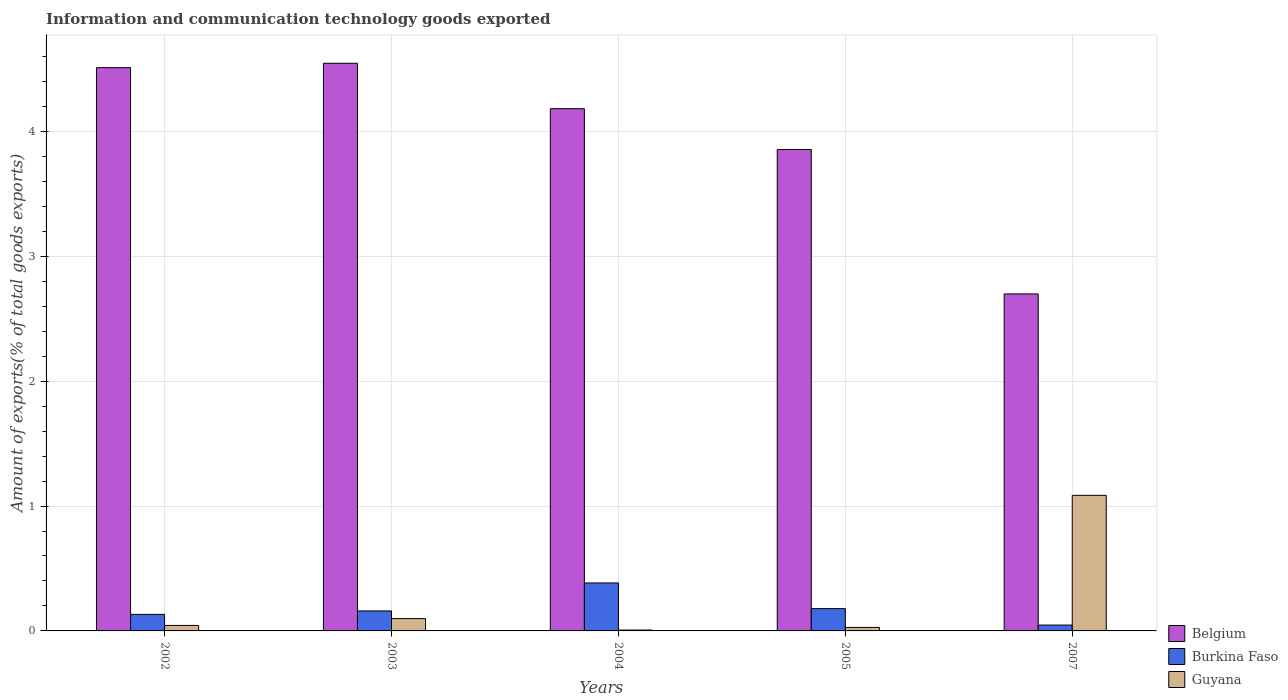How many different coloured bars are there?
Provide a short and direct response. 3. How many groups of bars are there?
Your answer should be compact. 5. How many bars are there on the 3rd tick from the right?
Make the answer very short. 3. What is the amount of goods exported in Belgium in 2005?
Keep it short and to the point. 3.86. Across all years, what is the maximum amount of goods exported in Guyana?
Ensure brevity in your answer.  1.09. Across all years, what is the minimum amount of goods exported in Guyana?
Make the answer very short. 0.01. In which year was the amount of goods exported in Burkina Faso maximum?
Offer a terse response. 2004. In which year was the amount of goods exported in Burkina Faso minimum?
Offer a terse response. 2007. What is the total amount of goods exported in Burkina Faso in the graph?
Give a very brief answer. 0.9. What is the difference between the amount of goods exported in Burkina Faso in 2005 and that in 2007?
Offer a very short reply. 0.13. What is the difference between the amount of goods exported in Guyana in 2005 and the amount of goods exported in Burkina Faso in 2002?
Keep it short and to the point. -0.1. What is the average amount of goods exported in Belgium per year?
Keep it short and to the point. 3.96. In the year 2007, what is the difference between the amount of goods exported in Burkina Faso and amount of goods exported in Belgium?
Make the answer very short. -2.65. In how many years, is the amount of goods exported in Belgium greater than 3 %?
Your response must be concise. 4. What is the ratio of the amount of goods exported in Guyana in 2002 to that in 2005?
Your response must be concise. 1.57. Is the difference between the amount of goods exported in Burkina Faso in 2003 and 2007 greater than the difference between the amount of goods exported in Belgium in 2003 and 2007?
Your response must be concise. No. What is the difference between the highest and the second highest amount of goods exported in Belgium?
Give a very brief answer. 0.04. What is the difference between the highest and the lowest amount of goods exported in Guyana?
Provide a succinct answer. 1.08. Is the sum of the amount of goods exported in Guyana in 2002 and 2005 greater than the maximum amount of goods exported in Burkina Faso across all years?
Your answer should be very brief. No. What does the 3rd bar from the left in 2002 represents?
Your answer should be compact. Guyana. What does the 2nd bar from the right in 2005 represents?
Keep it short and to the point. Burkina Faso. How many bars are there?
Offer a very short reply. 15. How many years are there in the graph?
Make the answer very short. 5. Does the graph contain any zero values?
Make the answer very short. No. What is the title of the graph?
Your answer should be very brief. Information and communication technology goods exported. Does "Cameroon" appear as one of the legend labels in the graph?
Your response must be concise. No. What is the label or title of the X-axis?
Give a very brief answer. Years. What is the label or title of the Y-axis?
Provide a succinct answer. Amount of exports(% of total goods exports). What is the Amount of exports(% of total goods exports) of Belgium in 2002?
Give a very brief answer. 4.51. What is the Amount of exports(% of total goods exports) of Burkina Faso in 2002?
Provide a succinct answer. 0.13. What is the Amount of exports(% of total goods exports) of Guyana in 2002?
Your answer should be very brief. 0.04. What is the Amount of exports(% of total goods exports) of Belgium in 2003?
Your response must be concise. 4.55. What is the Amount of exports(% of total goods exports) in Burkina Faso in 2003?
Make the answer very short. 0.16. What is the Amount of exports(% of total goods exports) of Guyana in 2003?
Offer a terse response. 0.1. What is the Amount of exports(% of total goods exports) in Belgium in 2004?
Your answer should be compact. 4.18. What is the Amount of exports(% of total goods exports) of Burkina Faso in 2004?
Provide a succinct answer. 0.38. What is the Amount of exports(% of total goods exports) in Guyana in 2004?
Your answer should be compact. 0.01. What is the Amount of exports(% of total goods exports) in Belgium in 2005?
Make the answer very short. 3.86. What is the Amount of exports(% of total goods exports) in Burkina Faso in 2005?
Provide a succinct answer. 0.18. What is the Amount of exports(% of total goods exports) of Guyana in 2005?
Give a very brief answer. 0.03. What is the Amount of exports(% of total goods exports) in Belgium in 2007?
Make the answer very short. 2.7. What is the Amount of exports(% of total goods exports) of Burkina Faso in 2007?
Offer a very short reply. 0.05. What is the Amount of exports(% of total goods exports) in Guyana in 2007?
Keep it short and to the point. 1.09. Across all years, what is the maximum Amount of exports(% of total goods exports) of Belgium?
Provide a short and direct response. 4.55. Across all years, what is the maximum Amount of exports(% of total goods exports) in Burkina Faso?
Keep it short and to the point. 0.38. Across all years, what is the maximum Amount of exports(% of total goods exports) of Guyana?
Provide a short and direct response. 1.09. Across all years, what is the minimum Amount of exports(% of total goods exports) of Belgium?
Provide a short and direct response. 2.7. Across all years, what is the minimum Amount of exports(% of total goods exports) of Burkina Faso?
Your answer should be very brief. 0.05. Across all years, what is the minimum Amount of exports(% of total goods exports) of Guyana?
Keep it short and to the point. 0.01. What is the total Amount of exports(% of total goods exports) in Belgium in the graph?
Provide a succinct answer. 19.79. What is the total Amount of exports(% of total goods exports) in Burkina Faso in the graph?
Keep it short and to the point. 0.9. What is the total Amount of exports(% of total goods exports) of Guyana in the graph?
Make the answer very short. 1.26. What is the difference between the Amount of exports(% of total goods exports) of Belgium in 2002 and that in 2003?
Ensure brevity in your answer.  -0.04. What is the difference between the Amount of exports(% of total goods exports) of Burkina Faso in 2002 and that in 2003?
Your answer should be very brief. -0.03. What is the difference between the Amount of exports(% of total goods exports) of Guyana in 2002 and that in 2003?
Provide a short and direct response. -0.05. What is the difference between the Amount of exports(% of total goods exports) in Belgium in 2002 and that in 2004?
Keep it short and to the point. 0.33. What is the difference between the Amount of exports(% of total goods exports) of Burkina Faso in 2002 and that in 2004?
Provide a short and direct response. -0.25. What is the difference between the Amount of exports(% of total goods exports) in Guyana in 2002 and that in 2004?
Your response must be concise. 0.04. What is the difference between the Amount of exports(% of total goods exports) in Belgium in 2002 and that in 2005?
Offer a terse response. 0.66. What is the difference between the Amount of exports(% of total goods exports) of Burkina Faso in 2002 and that in 2005?
Ensure brevity in your answer.  -0.05. What is the difference between the Amount of exports(% of total goods exports) of Guyana in 2002 and that in 2005?
Keep it short and to the point. 0.02. What is the difference between the Amount of exports(% of total goods exports) of Belgium in 2002 and that in 2007?
Your answer should be very brief. 1.81. What is the difference between the Amount of exports(% of total goods exports) in Burkina Faso in 2002 and that in 2007?
Ensure brevity in your answer.  0.09. What is the difference between the Amount of exports(% of total goods exports) of Guyana in 2002 and that in 2007?
Provide a succinct answer. -1.04. What is the difference between the Amount of exports(% of total goods exports) in Belgium in 2003 and that in 2004?
Make the answer very short. 0.36. What is the difference between the Amount of exports(% of total goods exports) in Burkina Faso in 2003 and that in 2004?
Offer a very short reply. -0.22. What is the difference between the Amount of exports(% of total goods exports) of Guyana in 2003 and that in 2004?
Give a very brief answer. 0.09. What is the difference between the Amount of exports(% of total goods exports) in Belgium in 2003 and that in 2005?
Provide a succinct answer. 0.69. What is the difference between the Amount of exports(% of total goods exports) of Burkina Faso in 2003 and that in 2005?
Your response must be concise. -0.02. What is the difference between the Amount of exports(% of total goods exports) of Guyana in 2003 and that in 2005?
Your answer should be compact. 0.07. What is the difference between the Amount of exports(% of total goods exports) of Belgium in 2003 and that in 2007?
Provide a short and direct response. 1.85. What is the difference between the Amount of exports(% of total goods exports) in Burkina Faso in 2003 and that in 2007?
Give a very brief answer. 0.11. What is the difference between the Amount of exports(% of total goods exports) of Guyana in 2003 and that in 2007?
Give a very brief answer. -0.99. What is the difference between the Amount of exports(% of total goods exports) of Belgium in 2004 and that in 2005?
Give a very brief answer. 0.33. What is the difference between the Amount of exports(% of total goods exports) in Burkina Faso in 2004 and that in 2005?
Ensure brevity in your answer.  0.21. What is the difference between the Amount of exports(% of total goods exports) in Guyana in 2004 and that in 2005?
Your answer should be very brief. -0.02. What is the difference between the Amount of exports(% of total goods exports) in Belgium in 2004 and that in 2007?
Keep it short and to the point. 1.48. What is the difference between the Amount of exports(% of total goods exports) of Burkina Faso in 2004 and that in 2007?
Offer a terse response. 0.34. What is the difference between the Amount of exports(% of total goods exports) of Guyana in 2004 and that in 2007?
Your answer should be very brief. -1.08. What is the difference between the Amount of exports(% of total goods exports) of Belgium in 2005 and that in 2007?
Your answer should be compact. 1.16. What is the difference between the Amount of exports(% of total goods exports) in Burkina Faso in 2005 and that in 2007?
Your answer should be very brief. 0.13. What is the difference between the Amount of exports(% of total goods exports) in Guyana in 2005 and that in 2007?
Offer a very short reply. -1.06. What is the difference between the Amount of exports(% of total goods exports) in Belgium in 2002 and the Amount of exports(% of total goods exports) in Burkina Faso in 2003?
Give a very brief answer. 4.35. What is the difference between the Amount of exports(% of total goods exports) in Belgium in 2002 and the Amount of exports(% of total goods exports) in Guyana in 2003?
Provide a short and direct response. 4.41. What is the difference between the Amount of exports(% of total goods exports) in Burkina Faso in 2002 and the Amount of exports(% of total goods exports) in Guyana in 2003?
Keep it short and to the point. 0.03. What is the difference between the Amount of exports(% of total goods exports) in Belgium in 2002 and the Amount of exports(% of total goods exports) in Burkina Faso in 2004?
Offer a very short reply. 4.13. What is the difference between the Amount of exports(% of total goods exports) of Belgium in 2002 and the Amount of exports(% of total goods exports) of Guyana in 2004?
Give a very brief answer. 4.5. What is the difference between the Amount of exports(% of total goods exports) in Burkina Faso in 2002 and the Amount of exports(% of total goods exports) in Guyana in 2004?
Offer a very short reply. 0.13. What is the difference between the Amount of exports(% of total goods exports) in Belgium in 2002 and the Amount of exports(% of total goods exports) in Burkina Faso in 2005?
Keep it short and to the point. 4.33. What is the difference between the Amount of exports(% of total goods exports) in Belgium in 2002 and the Amount of exports(% of total goods exports) in Guyana in 2005?
Ensure brevity in your answer.  4.48. What is the difference between the Amount of exports(% of total goods exports) in Burkina Faso in 2002 and the Amount of exports(% of total goods exports) in Guyana in 2005?
Offer a very short reply. 0.1. What is the difference between the Amount of exports(% of total goods exports) in Belgium in 2002 and the Amount of exports(% of total goods exports) in Burkina Faso in 2007?
Your answer should be compact. 4.46. What is the difference between the Amount of exports(% of total goods exports) in Belgium in 2002 and the Amount of exports(% of total goods exports) in Guyana in 2007?
Ensure brevity in your answer.  3.42. What is the difference between the Amount of exports(% of total goods exports) in Burkina Faso in 2002 and the Amount of exports(% of total goods exports) in Guyana in 2007?
Your answer should be compact. -0.95. What is the difference between the Amount of exports(% of total goods exports) of Belgium in 2003 and the Amount of exports(% of total goods exports) of Burkina Faso in 2004?
Provide a succinct answer. 4.16. What is the difference between the Amount of exports(% of total goods exports) in Belgium in 2003 and the Amount of exports(% of total goods exports) in Guyana in 2004?
Keep it short and to the point. 4.54. What is the difference between the Amount of exports(% of total goods exports) in Burkina Faso in 2003 and the Amount of exports(% of total goods exports) in Guyana in 2004?
Offer a terse response. 0.15. What is the difference between the Amount of exports(% of total goods exports) of Belgium in 2003 and the Amount of exports(% of total goods exports) of Burkina Faso in 2005?
Provide a short and direct response. 4.37. What is the difference between the Amount of exports(% of total goods exports) of Belgium in 2003 and the Amount of exports(% of total goods exports) of Guyana in 2005?
Offer a very short reply. 4.52. What is the difference between the Amount of exports(% of total goods exports) of Burkina Faso in 2003 and the Amount of exports(% of total goods exports) of Guyana in 2005?
Provide a short and direct response. 0.13. What is the difference between the Amount of exports(% of total goods exports) in Belgium in 2003 and the Amount of exports(% of total goods exports) in Burkina Faso in 2007?
Offer a terse response. 4.5. What is the difference between the Amount of exports(% of total goods exports) in Belgium in 2003 and the Amount of exports(% of total goods exports) in Guyana in 2007?
Ensure brevity in your answer.  3.46. What is the difference between the Amount of exports(% of total goods exports) of Burkina Faso in 2003 and the Amount of exports(% of total goods exports) of Guyana in 2007?
Keep it short and to the point. -0.93. What is the difference between the Amount of exports(% of total goods exports) in Belgium in 2004 and the Amount of exports(% of total goods exports) in Burkina Faso in 2005?
Your response must be concise. 4. What is the difference between the Amount of exports(% of total goods exports) of Belgium in 2004 and the Amount of exports(% of total goods exports) of Guyana in 2005?
Keep it short and to the point. 4.15. What is the difference between the Amount of exports(% of total goods exports) in Burkina Faso in 2004 and the Amount of exports(% of total goods exports) in Guyana in 2005?
Your answer should be compact. 0.36. What is the difference between the Amount of exports(% of total goods exports) of Belgium in 2004 and the Amount of exports(% of total goods exports) of Burkina Faso in 2007?
Provide a short and direct response. 4.14. What is the difference between the Amount of exports(% of total goods exports) in Belgium in 2004 and the Amount of exports(% of total goods exports) in Guyana in 2007?
Offer a terse response. 3.1. What is the difference between the Amount of exports(% of total goods exports) of Burkina Faso in 2004 and the Amount of exports(% of total goods exports) of Guyana in 2007?
Your answer should be compact. -0.7. What is the difference between the Amount of exports(% of total goods exports) in Belgium in 2005 and the Amount of exports(% of total goods exports) in Burkina Faso in 2007?
Keep it short and to the point. 3.81. What is the difference between the Amount of exports(% of total goods exports) of Belgium in 2005 and the Amount of exports(% of total goods exports) of Guyana in 2007?
Make the answer very short. 2.77. What is the difference between the Amount of exports(% of total goods exports) in Burkina Faso in 2005 and the Amount of exports(% of total goods exports) in Guyana in 2007?
Keep it short and to the point. -0.91. What is the average Amount of exports(% of total goods exports) in Belgium per year?
Offer a terse response. 3.96. What is the average Amount of exports(% of total goods exports) in Burkina Faso per year?
Your answer should be compact. 0.18. What is the average Amount of exports(% of total goods exports) in Guyana per year?
Provide a short and direct response. 0.25. In the year 2002, what is the difference between the Amount of exports(% of total goods exports) in Belgium and Amount of exports(% of total goods exports) in Burkina Faso?
Keep it short and to the point. 4.38. In the year 2002, what is the difference between the Amount of exports(% of total goods exports) in Belgium and Amount of exports(% of total goods exports) in Guyana?
Keep it short and to the point. 4.47. In the year 2002, what is the difference between the Amount of exports(% of total goods exports) in Burkina Faso and Amount of exports(% of total goods exports) in Guyana?
Provide a short and direct response. 0.09. In the year 2003, what is the difference between the Amount of exports(% of total goods exports) of Belgium and Amount of exports(% of total goods exports) of Burkina Faso?
Offer a very short reply. 4.39. In the year 2003, what is the difference between the Amount of exports(% of total goods exports) in Belgium and Amount of exports(% of total goods exports) in Guyana?
Keep it short and to the point. 4.45. In the year 2003, what is the difference between the Amount of exports(% of total goods exports) in Burkina Faso and Amount of exports(% of total goods exports) in Guyana?
Offer a very short reply. 0.06. In the year 2004, what is the difference between the Amount of exports(% of total goods exports) in Belgium and Amount of exports(% of total goods exports) in Burkina Faso?
Your answer should be compact. 3.8. In the year 2004, what is the difference between the Amount of exports(% of total goods exports) of Belgium and Amount of exports(% of total goods exports) of Guyana?
Offer a terse response. 4.17. In the year 2004, what is the difference between the Amount of exports(% of total goods exports) of Burkina Faso and Amount of exports(% of total goods exports) of Guyana?
Ensure brevity in your answer.  0.38. In the year 2005, what is the difference between the Amount of exports(% of total goods exports) of Belgium and Amount of exports(% of total goods exports) of Burkina Faso?
Ensure brevity in your answer.  3.68. In the year 2005, what is the difference between the Amount of exports(% of total goods exports) of Belgium and Amount of exports(% of total goods exports) of Guyana?
Make the answer very short. 3.83. In the year 2005, what is the difference between the Amount of exports(% of total goods exports) of Burkina Faso and Amount of exports(% of total goods exports) of Guyana?
Provide a short and direct response. 0.15. In the year 2007, what is the difference between the Amount of exports(% of total goods exports) in Belgium and Amount of exports(% of total goods exports) in Burkina Faso?
Your answer should be compact. 2.65. In the year 2007, what is the difference between the Amount of exports(% of total goods exports) in Belgium and Amount of exports(% of total goods exports) in Guyana?
Your answer should be compact. 1.61. In the year 2007, what is the difference between the Amount of exports(% of total goods exports) of Burkina Faso and Amount of exports(% of total goods exports) of Guyana?
Offer a very short reply. -1.04. What is the ratio of the Amount of exports(% of total goods exports) of Belgium in 2002 to that in 2003?
Make the answer very short. 0.99. What is the ratio of the Amount of exports(% of total goods exports) of Burkina Faso in 2002 to that in 2003?
Your answer should be compact. 0.83. What is the ratio of the Amount of exports(% of total goods exports) of Guyana in 2002 to that in 2003?
Give a very brief answer. 0.45. What is the ratio of the Amount of exports(% of total goods exports) of Belgium in 2002 to that in 2004?
Keep it short and to the point. 1.08. What is the ratio of the Amount of exports(% of total goods exports) in Burkina Faso in 2002 to that in 2004?
Ensure brevity in your answer.  0.34. What is the ratio of the Amount of exports(% of total goods exports) of Guyana in 2002 to that in 2004?
Provide a short and direct response. 6.3. What is the ratio of the Amount of exports(% of total goods exports) of Belgium in 2002 to that in 2005?
Give a very brief answer. 1.17. What is the ratio of the Amount of exports(% of total goods exports) of Burkina Faso in 2002 to that in 2005?
Your answer should be compact. 0.74. What is the ratio of the Amount of exports(% of total goods exports) of Guyana in 2002 to that in 2005?
Keep it short and to the point. 1.57. What is the ratio of the Amount of exports(% of total goods exports) of Belgium in 2002 to that in 2007?
Keep it short and to the point. 1.67. What is the ratio of the Amount of exports(% of total goods exports) in Burkina Faso in 2002 to that in 2007?
Make the answer very short. 2.83. What is the ratio of the Amount of exports(% of total goods exports) of Guyana in 2002 to that in 2007?
Offer a terse response. 0.04. What is the ratio of the Amount of exports(% of total goods exports) in Belgium in 2003 to that in 2004?
Your answer should be compact. 1.09. What is the ratio of the Amount of exports(% of total goods exports) in Burkina Faso in 2003 to that in 2004?
Make the answer very short. 0.42. What is the ratio of the Amount of exports(% of total goods exports) in Guyana in 2003 to that in 2004?
Your response must be concise. 14.12. What is the ratio of the Amount of exports(% of total goods exports) of Belgium in 2003 to that in 2005?
Ensure brevity in your answer.  1.18. What is the ratio of the Amount of exports(% of total goods exports) of Burkina Faso in 2003 to that in 2005?
Provide a short and direct response. 0.9. What is the ratio of the Amount of exports(% of total goods exports) of Guyana in 2003 to that in 2005?
Ensure brevity in your answer.  3.53. What is the ratio of the Amount of exports(% of total goods exports) in Belgium in 2003 to that in 2007?
Your answer should be very brief. 1.68. What is the ratio of the Amount of exports(% of total goods exports) of Burkina Faso in 2003 to that in 2007?
Offer a very short reply. 3.41. What is the ratio of the Amount of exports(% of total goods exports) of Guyana in 2003 to that in 2007?
Provide a succinct answer. 0.09. What is the ratio of the Amount of exports(% of total goods exports) in Belgium in 2004 to that in 2005?
Offer a terse response. 1.08. What is the ratio of the Amount of exports(% of total goods exports) in Burkina Faso in 2004 to that in 2005?
Your answer should be compact. 2.15. What is the ratio of the Amount of exports(% of total goods exports) in Guyana in 2004 to that in 2005?
Offer a very short reply. 0.25. What is the ratio of the Amount of exports(% of total goods exports) of Belgium in 2004 to that in 2007?
Your response must be concise. 1.55. What is the ratio of the Amount of exports(% of total goods exports) in Burkina Faso in 2004 to that in 2007?
Offer a very short reply. 8.19. What is the ratio of the Amount of exports(% of total goods exports) in Guyana in 2004 to that in 2007?
Your answer should be very brief. 0.01. What is the ratio of the Amount of exports(% of total goods exports) in Belgium in 2005 to that in 2007?
Keep it short and to the point. 1.43. What is the ratio of the Amount of exports(% of total goods exports) in Burkina Faso in 2005 to that in 2007?
Make the answer very short. 3.81. What is the ratio of the Amount of exports(% of total goods exports) in Guyana in 2005 to that in 2007?
Your answer should be compact. 0.03. What is the difference between the highest and the second highest Amount of exports(% of total goods exports) of Belgium?
Provide a succinct answer. 0.04. What is the difference between the highest and the second highest Amount of exports(% of total goods exports) in Burkina Faso?
Offer a very short reply. 0.21. What is the difference between the highest and the lowest Amount of exports(% of total goods exports) in Belgium?
Keep it short and to the point. 1.85. What is the difference between the highest and the lowest Amount of exports(% of total goods exports) in Burkina Faso?
Make the answer very short. 0.34. What is the difference between the highest and the lowest Amount of exports(% of total goods exports) of Guyana?
Offer a very short reply. 1.08. 